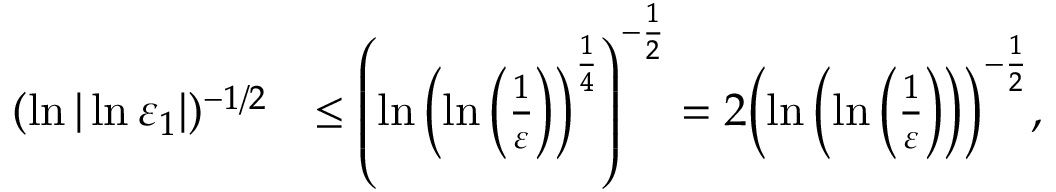<formula> <loc_0><loc_0><loc_500><loc_500>\begin{array} { r l } { ( \ln | \ln \varepsilon _ { 1 } | ) ^ { - 1 / 2 } } & { \leq { \left ( \ln { \left ( \ln \left ( { \frac { 1 } { \varepsilon } } \right ) \right ) ^ { { \frac { 1 } { 4 } } } } \right ) ^ { - { \frac { 1 } { 2 } } } } = 2 { \left ( \ln \left ( \ln \left ( { \frac { 1 } { \varepsilon } } \right ) \right ) \right ) ^ { - { \frac { 1 } { 2 } } } } , } \end{array}</formula> 